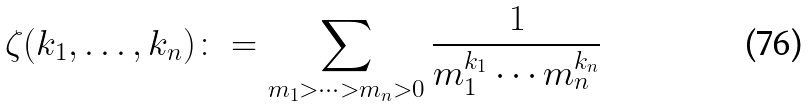Convert formula to latex. <formula><loc_0><loc_0><loc_500><loc_500>\zeta ( k _ { 1 } , \dots , k _ { n } ) \colon = \sum _ { m _ { 1 } > \cdots > m _ { n } > 0 } \frac { 1 } { m _ { 1 } ^ { k _ { 1 } } \cdots m _ { n } ^ { k _ { n } } }</formula> 